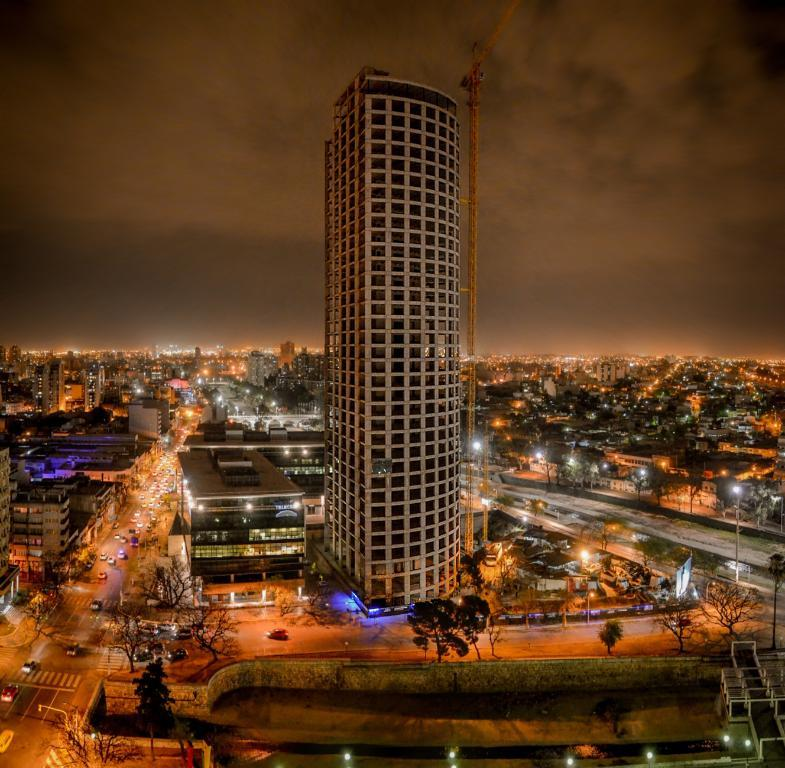What is located in the center of the image? There are buildings, lights, poles, vehicles, and trees in the center of the image. Can you describe the lighting in the center of the image? There are lights in the center of the image. What type of structures are present in the center of the image? There are buildings and poles in the center of the image. What else can be seen in the center of the image? There are vehicles in the center of the image. What is visible in the background of the image? The sky is visible in the background of the image, and there are clouds in the background as well. What type of education can be seen taking place in the image? There is no indication of education taking place in the image. What role does lead play in the image? There is no mention of lead or any metallic elements in the image. 